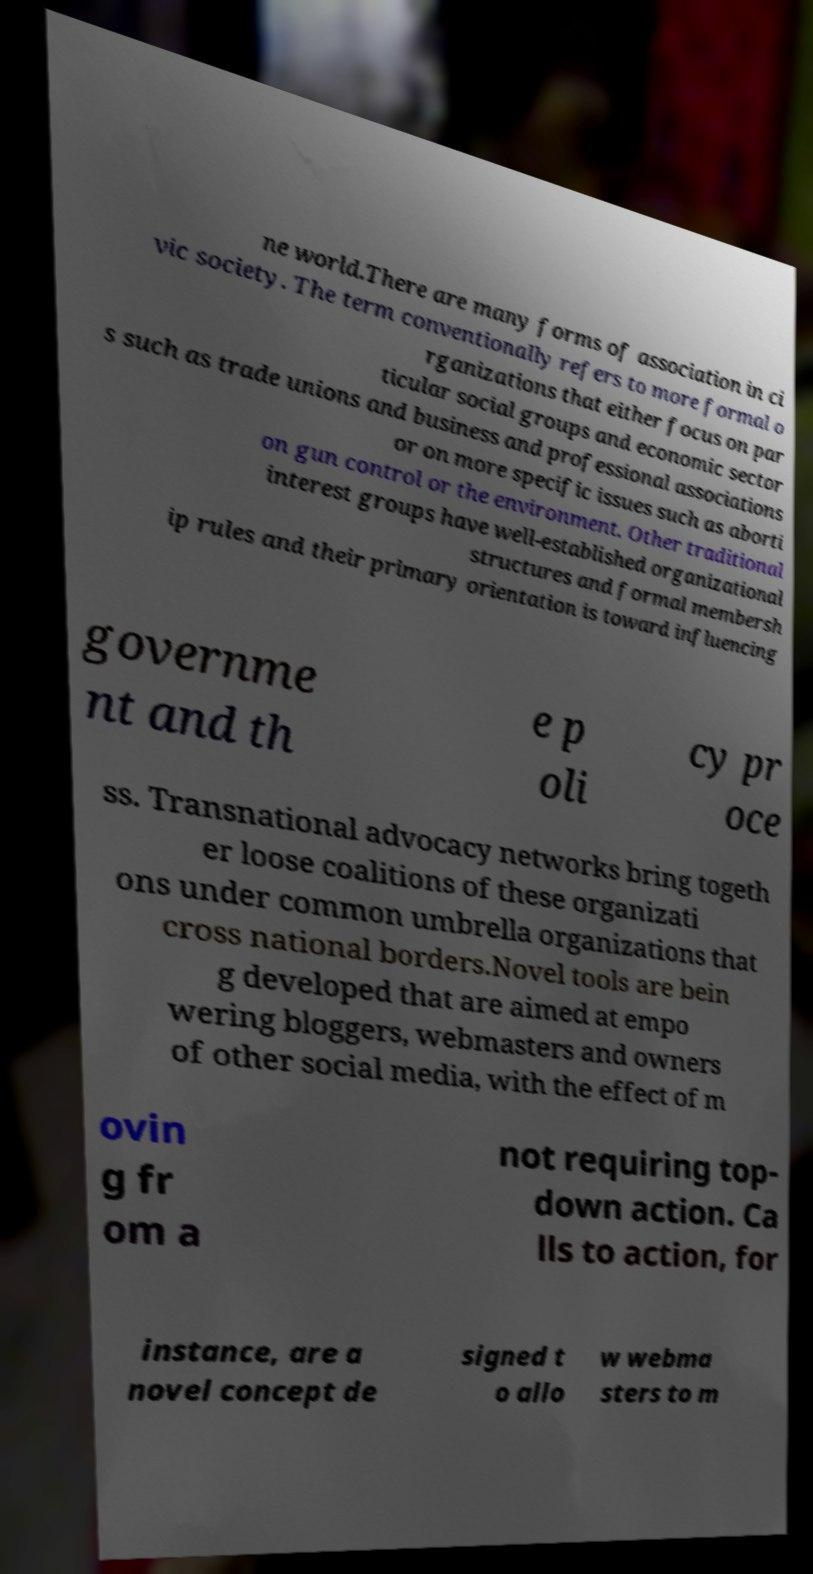Please read and relay the text visible in this image. What does it say? ne world.There are many forms of association in ci vic society. The term conventionally refers to more formal o rganizations that either focus on par ticular social groups and economic sector s such as trade unions and business and professional associations or on more specific issues such as aborti on gun control or the environment. Other traditional interest groups have well-established organizational structures and formal membersh ip rules and their primary orientation is toward influencing governme nt and th e p oli cy pr oce ss. Transnational advocacy networks bring togeth er loose coalitions of these organizati ons under common umbrella organizations that cross national borders.Novel tools are bein g developed that are aimed at empo wering bloggers, webmasters and owners of other social media, with the effect of m ovin g fr om a not requiring top- down action. Ca lls to action, for instance, are a novel concept de signed t o allo w webma sters to m 